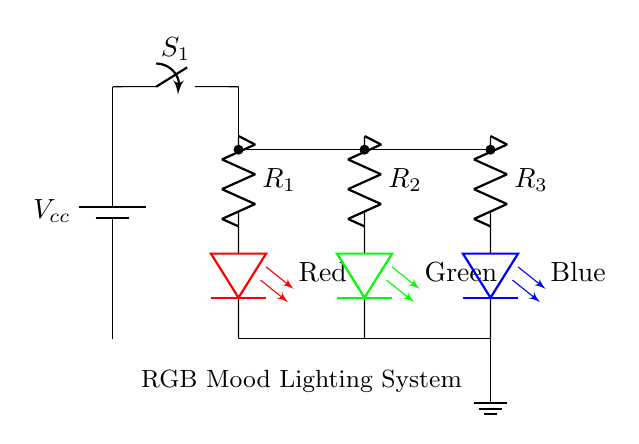What is the type of circuit used in this diagram? The diagram illustrates a parallel circuit type because all LEDs are connected along separate paths to a common voltage source, thus sharing the same voltage while experiencing different currents.
Answer: Parallel How many LEDs are present in this circuit? Count each LED individually; there are three distinct LEDs: Red, Green, and Blue.
Answer: Three What is the purpose of the resistors in this circuit? The resistors limit the current flowing through each LED, preventing excessive current and potential damage by ensuring each LED operates at its rated current.
Answer: Current limiting What color is the LED connected to resistor R1? Inspect the diagram specifically at the branch connected to R1; it identifies the LED as Red.
Answer: Red What can you conclude about the voltage across each LED? In a parallel circuit, the voltage across each component is equal to the source voltage, therefore, each LED experiences the same voltage as supplied by the battery, which is denoted as Vcc.
Answer: Vcc Which component is used to switch the lighting system on and off? The switch labeled S1 is the component used for controlling the power flow, allowing the user to turn the entire circuit on or off.
Answer: Switch 